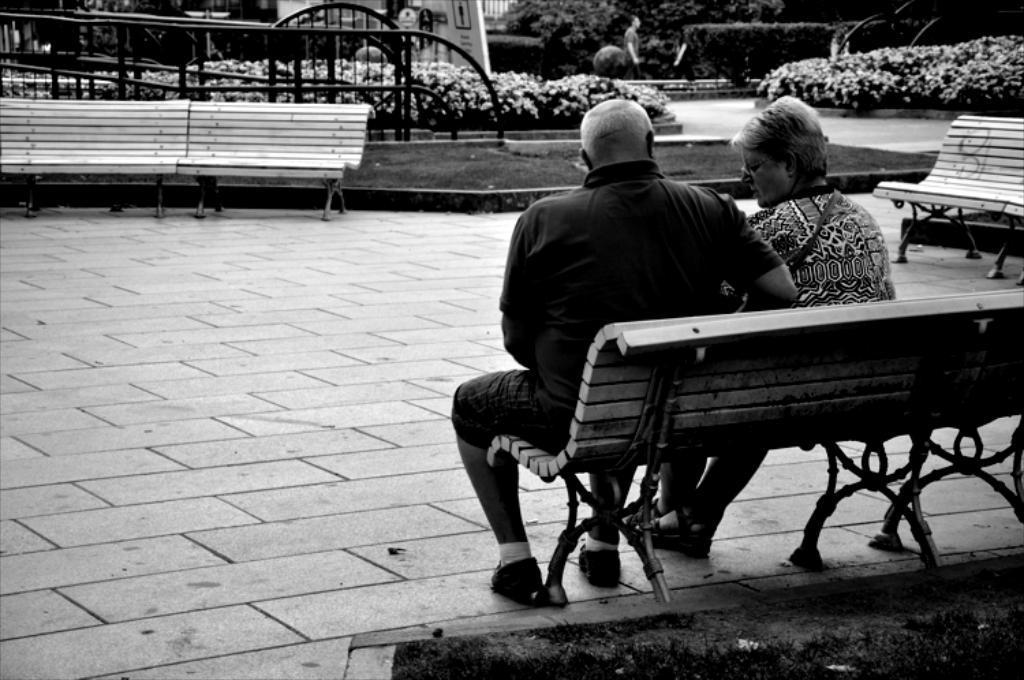Describe this image in one or two sentences. In this picture I can observe a couple sitting on the bench. This is a black and white image. In the background I can observe a railing and some plants. 